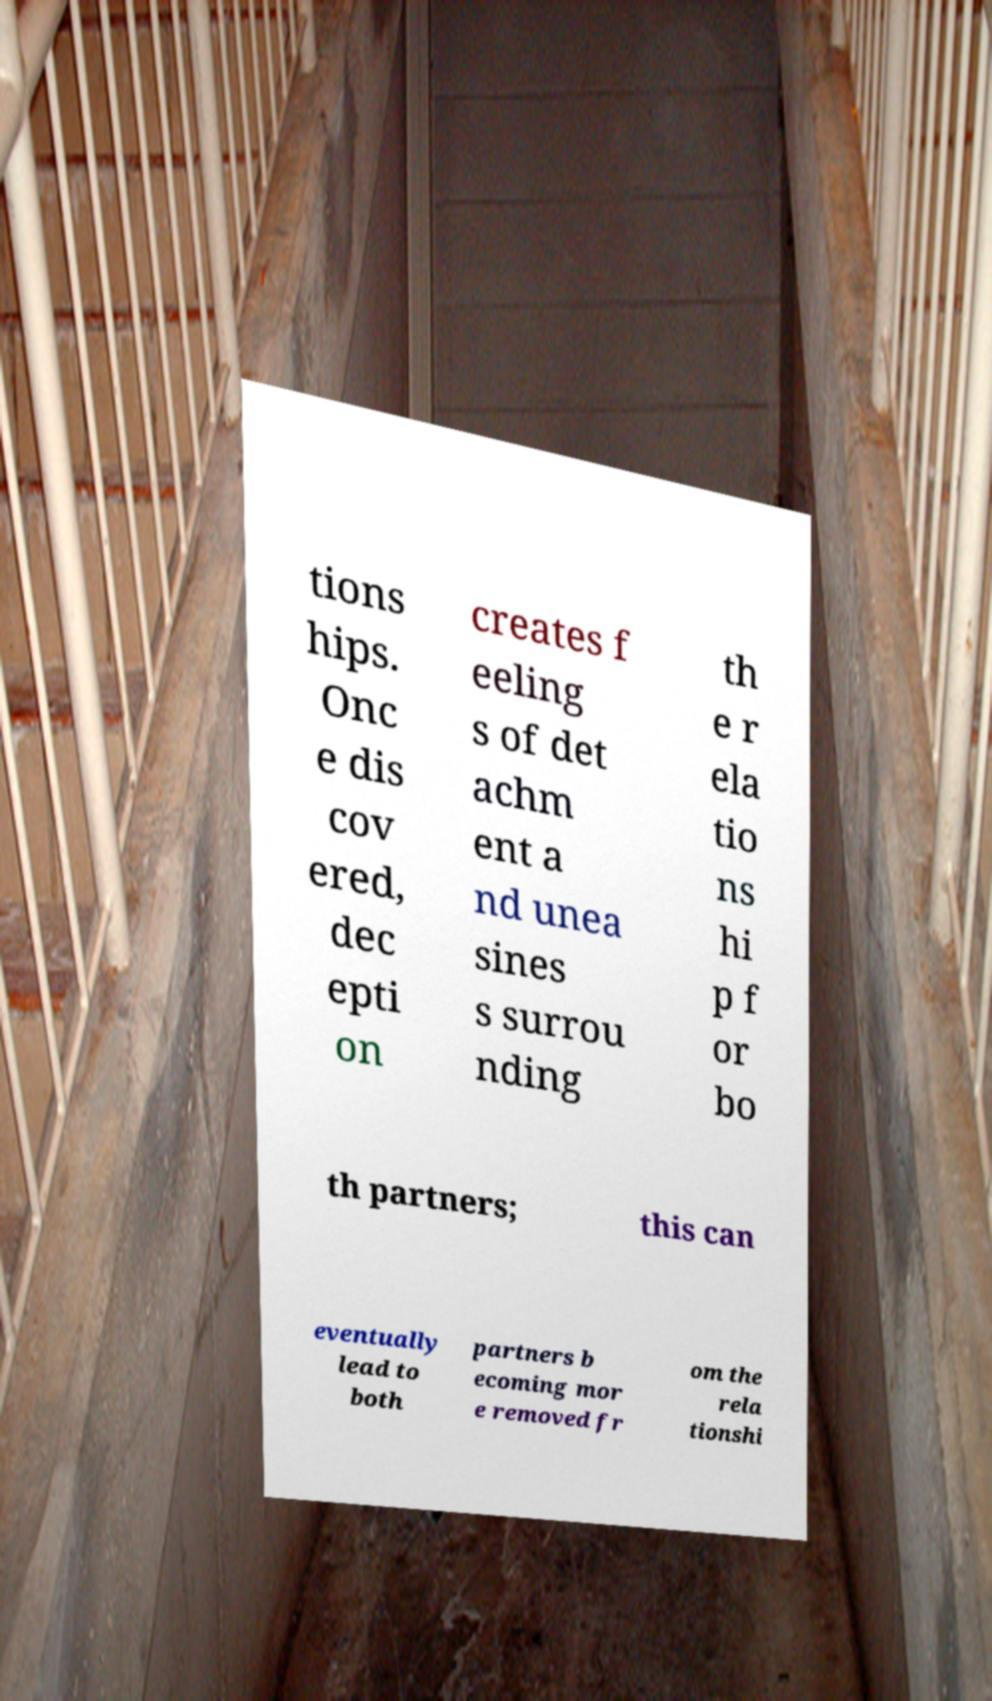There's text embedded in this image that I need extracted. Can you transcribe it verbatim? tions hips. Onc e dis cov ered, dec epti on creates f eeling s of det achm ent a nd unea sines s surrou nding th e r ela tio ns hi p f or bo th partners; this can eventually lead to both partners b ecoming mor e removed fr om the rela tionshi 